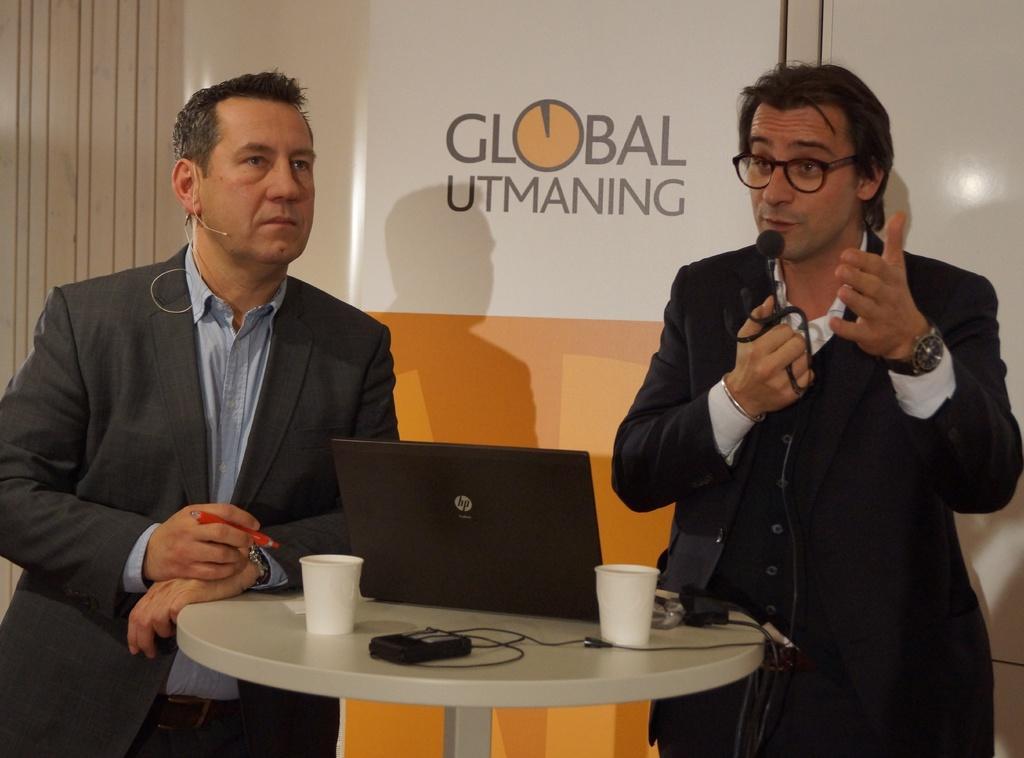Can you describe this image briefly? In this picture we can see a man standing and holding a microphone in his hands, and in front here is the table and laptop and some objects on it, and here a person is standing and holding a pen in the hand. 